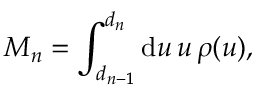<formula> <loc_0><loc_0><loc_500><loc_500>M _ { n } = \int _ { d _ { n - 1 } } ^ { d _ { n } } d u \, u \, \rho ( u ) ,</formula> 